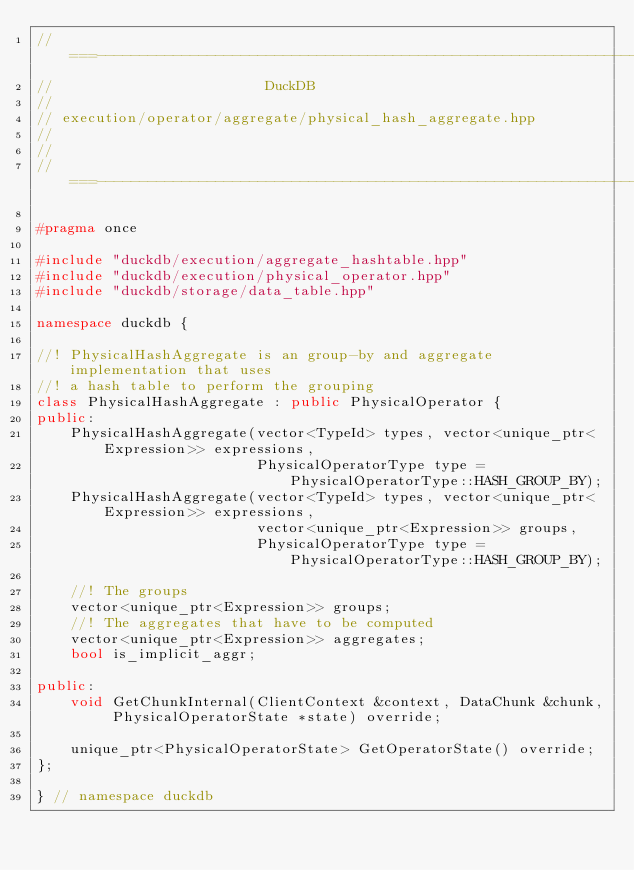<code> <loc_0><loc_0><loc_500><loc_500><_C++_>//===----------------------------------------------------------------------===//
//                         DuckDB
//
// execution/operator/aggregate/physical_hash_aggregate.hpp
//
//
//===----------------------------------------------------------------------===//

#pragma once

#include "duckdb/execution/aggregate_hashtable.hpp"
#include "duckdb/execution/physical_operator.hpp"
#include "duckdb/storage/data_table.hpp"

namespace duckdb {

//! PhysicalHashAggregate is an group-by and aggregate implementation that uses
//! a hash table to perform the grouping
class PhysicalHashAggregate : public PhysicalOperator {
public:
	PhysicalHashAggregate(vector<TypeId> types, vector<unique_ptr<Expression>> expressions,
	                      PhysicalOperatorType type = PhysicalOperatorType::HASH_GROUP_BY);
	PhysicalHashAggregate(vector<TypeId> types, vector<unique_ptr<Expression>> expressions,
	                      vector<unique_ptr<Expression>> groups,
	                      PhysicalOperatorType type = PhysicalOperatorType::HASH_GROUP_BY);

	//! The groups
	vector<unique_ptr<Expression>> groups;
	//! The aggregates that have to be computed
	vector<unique_ptr<Expression>> aggregates;
	bool is_implicit_aggr;

public:
	void GetChunkInternal(ClientContext &context, DataChunk &chunk, PhysicalOperatorState *state) override;

	unique_ptr<PhysicalOperatorState> GetOperatorState() override;
};

} // namespace duckdb
</code> 